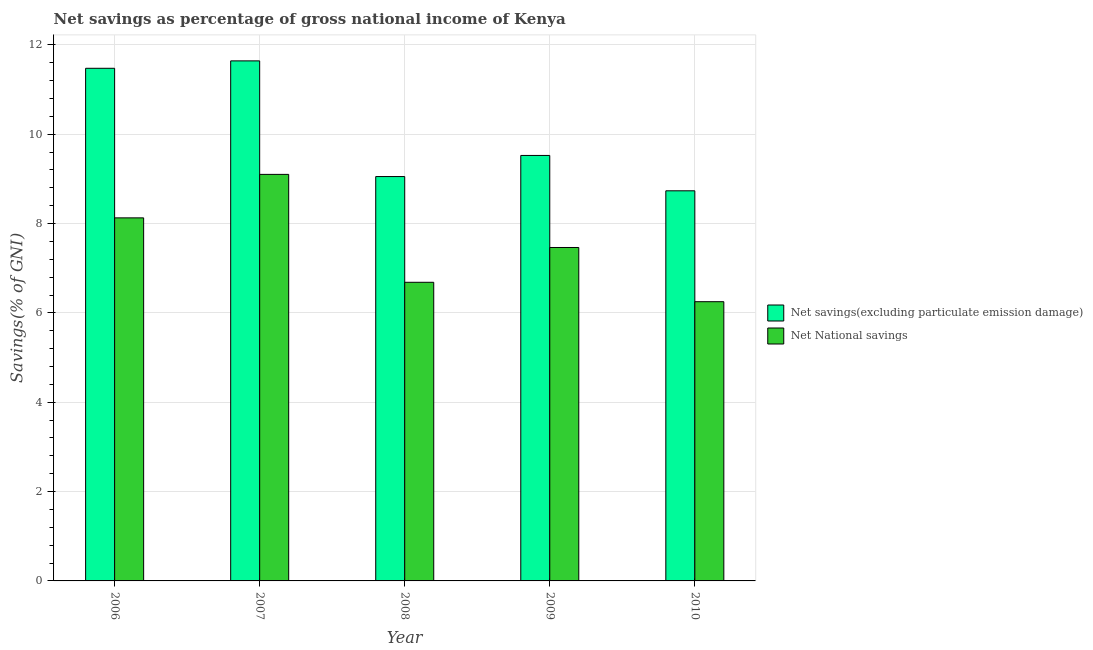How many different coloured bars are there?
Your answer should be very brief. 2. How many bars are there on the 3rd tick from the right?
Your answer should be very brief. 2. What is the net national savings in 2008?
Keep it short and to the point. 6.69. Across all years, what is the maximum net savings(excluding particulate emission damage)?
Give a very brief answer. 11.64. Across all years, what is the minimum net national savings?
Ensure brevity in your answer.  6.25. What is the total net savings(excluding particulate emission damage) in the graph?
Keep it short and to the point. 50.43. What is the difference between the net national savings in 2006 and that in 2010?
Ensure brevity in your answer.  1.88. What is the difference between the net savings(excluding particulate emission damage) in 2009 and the net national savings in 2010?
Offer a terse response. 0.79. What is the average net national savings per year?
Ensure brevity in your answer.  7.53. In how many years, is the net savings(excluding particulate emission damage) greater than 11.6 %?
Ensure brevity in your answer.  1. What is the ratio of the net savings(excluding particulate emission damage) in 2006 to that in 2007?
Offer a terse response. 0.99. Is the net national savings in 2006 less than that in 2010?
Give a very brief answer. No. Is the difference between the net national savings in 2009 and 2010 greater than the difference between the net savings(excluding particulate emission damage) in 2009 and 2010?
Offer a terse response. No. What is the difference between the highest and the second highest net national savings?
Make the answer very short. 0.97. What is the difference between the highest and the lowest net savings(excluding particulate emission damage)?
Make the answer very short. 2.91. In how many years, is the net savings(excluding particulate emission damage) greater than the average net savings(excluding particulate emission damage) taken over all years?
Offer a terse response. 2. Is the sum of the net savings(excluding particulate emission damage) in 2008 and 2009 greater than the maximum net national savings across all years?
Offer a very short reply. Yes. What does the 1st bar from the left in 2007 represents?
Provide a short and direct response. Net savings(excluding particulate emission damage). What does the 1st bar from the right in 2008 represents?
Provide a short and direct response. Net National savings. How many bars are there?
Provide a succinct answer. 10. How many years are there in the graph?
Your response must be concise. 5. What is the difference between two consecutive major ticks on the Y-axis?
Make the answer very short. 2. Does the graph contain grids?
Provide a succinct answer. Yes. How many legend labels are there?
Give a very brief answer. 2. What is the title of the graph?
Provide a succinct answer. Net savings as percentage of gross national income of Kenya. What is the label or title of the Y-axis?
Your answer should be very brief. Savings(% of GNI). What is the Savings(% of GNI) of Net savings(excluding particulate emission damage) in 2006?
Provide a short and direct response. 11.48. What is the Savings(% of GNI) of Net National savings in 2006?
Offer a terse response. 8.13. What is the Savings(% of GNI) of Net savings(excluding particulate emission damage) in 2007?
Provide a short and direct response. 11.64. What is the Savings(% of GNI) in Net National savings in 2007?
Offer a terse response. 9.1. What is the Savings(% of GNI) of Net savings(excluding particulate emission damage) in 2008?
Give a very brief answer. 9.05. What is the Savings(% of GNI) in Net National savings in 2008?
Your response must be concise. 6.69. What is the Savings(% of GNI) in Net savings(excluding particulate emission damage) in 2009?
Offer a very short reply. 9.53. What is the Savings(% of GNI) of Net National savings in 2009?
Provide a succinct answer. 7.46. What is the Savings(% of GNI) in Net savings(excluding particulate emission damage) in 2010?
Make the answer very short. 8.73. What is the Savings(% of GNI) in Net National savings in 2010?
Your response must be concise. 6.25. Across all years, what is the maximum Savings(% of GNI) of Net savings(excluding particulate emission damage)?
Provide a short and direct response. 11.64. Across all years, what is the maximum Savings(% of GNI) in Net National savings?
Your answer should be compact. 9.1. Across all years, what is the minimum Savings(% of GNI) of Net savings(excluding particulate emission damage)?
Your answer should be compact. 8.73. Across all years, what is the minimum Savings(% of GNI) of Net National savings?
Provide a short and direct response. 6.25. What is the total Savings(% of GNI) of Net savings(excluding particulate emission damage) in the graph?
Your answer should be compact. 50.43. What is the total Savings(% of GNI) in Net National savings in the graph?
Provide a short and direct response. 37.63. What is the difference between the Savings(% of GNI) in Net savings(excluding particulate emission damage) in 2006 and that in 2007?
Keep it short and to the point. -0.17. What is the difference between the Savings(% of GNI) in Net National savings in 2006 and that in 2007?
Offer a very short reply. -0.97. What is the difference between the Savings(% of GNI) in Net savings(excluding particulate emission damage) in 2006 and that in 2008?
Give a very brief answer. 2.42. What is the difference between the Savings(% of GNI) of Net National savings in 2006 and that in 2008?
Offer a terse response. 1.44. What is the difference between the Savings(% of GNI) of Net savings(excluding particulate emission damage) in 2006 and that in 2009?
Offer a very short reply. 1.95. What is the difference between the Savings(% of GNI) of Net National savings in 2006 and that in 2009?
Provide a succinct answer. 0.66. What is the difference between the Savings(% of GNI) in Net savings(excluding particulate emission damage) in 2006 and that in 2010?
Make the answer very short. 2.74. What is the difference between the Savings(% of GNI) in Net National savings in 2006 and that in 2010?
Make the answer very short. 1.88. What is the difference between the Savings(% of GNI) in Net savings(excluding particulate emission damage) in 2007 and that in 2008?
Your answer should be compact. 2.59. What is the difference between the Savings(% of GNI) in Net National savings in 2007 and that in 2008?
Make the answer very short. 2.42. What is the difference between the Savings(% of GNI) of Net savings(excluding particulate emission damage) in 2007 and that in 2009?
Ensure brevity in your answer.  2.12. What is the difference between the Savings(% of GNI) of Net National savings in 2007 and that in 2009?
Offer a terse response. 1.64. What is the difference between the Savings(% of GNI) in Net savings(excluding particulate emission damage) in 2007 and that in 2010?
Give a very brief answer. 2.91. What is the difference between the Savings(% of GNI) of Net National savings in 2007 and that in 2010?
Keep it short and to the point. 2.85. What is the difference between the Savings(% of GNI) of Net savings(excluding particulate emission damage) in 2008 and that in 2009?
Make the answer very short. -0.47. What is the difference between the Savings(% of GNI) of Net National savings in 2008 and that in 2009?
Offer a very short reply. -0.78. What is the difference between the Savings(% of GNI) in Net savings(excluding particulate emission damage) in 2008 and that in 2010?
Give a very brief answer. 0.32. What is the difference between the Savings(% of GNI) of Net National savings in 2008 and that in 2010?
Keep it short and to the point. 0.43. What is the difference between the Savings(% of GNI) of Net savings(excluding particulate emission damage) in 2009 and that in 2010?
Offer a terse response. 0.79. What is the difference between the Savings(% of GNI) of Net National savings in 2009 and that in 2010?
Give a very brief answer. 1.21. What is the difference between the Savings(% of GNI) of Net savings(excluding particulate emission damage) in 2006 and the Savings(% of GNI) of Net National savings in 2007?
Make the answer very short. 2.38. What is the difference between the Savings(% of GNI) of Net savings(excluding particulate emission damage) in 2006 and the Savings(% of GNI) of Net National savings in 2008?
Provide a succinct answer. 4.79. What is the difference between the Savings(% of GNI) in Net savings(excluding particulate emission damage) in 2006 and the Savings(% of GNI) in Net National savings in 2009?
Keep it short and to the point. 4.01. What is the difference between the Savings(% of GNI) of Net savings(excluding particulate emission damage) in 2006 and the Savings(% of GNI) of Net National savings in 2010?
Offer a very short reply. 5.23. What is the difference between the Savings(% of GNI) of Net savings(excluding particulate emission damage) in 2007 and the Savings(% of GNI) of Net National savings in 2008?
Offer a very short reply. 4.96. What is the difference between the Savings(% of GNI) in Net savings(excluding particulate emission damage) in 2007 and the Savings(% of GNI) in Net National savings in 2009?
Offer a very short reply. 4.18. What is the difference between the Savings(% of GNI) in Net savings(excluding particulate emission damage) in 2007 and the Savings(% of GNI) in Net National savings in 2010?
Offer a terse response. 5.39. What is the difference between the Savings(% of GNI) of Net savings(excluding particulate emission damage) in 2008 and the Savings(% of GNI) of Net National savings in 2009?
Provide a succinct answer. 1.59. What is the difference between the Savings(% of GNI) in Net savings(excluding particulate emission damage) in 2008 and the Savings(% of GNI) in Net National savings in 2010?
Provide a short and direct response. 2.8. What is the difference between the Savings(% of GNI) of Net savings(excluding particulate emission damage) in 2009 and the Savings(% of GNI) of Net National savings in 2010?
Give a very brief answer. 3.27. What is the average Savings(% of GNI) in Net savings(excluding particulate emission damage) per year?
Keep it short and to the point. 10.09. What is the average Savings(% of GNI) of Net National savings per year?
Your response must be concise. 7.53. In the year 2006, what is the difference between the Savings(% of GNI) in Net savings(excluding particulate emission damage) and Savings(% of GNI) in Net National savings?
Ensure brevity in your answer.  3.35. In the year 2007, what is the difference between the Savings(% of GNI) of Net savings(excluding particulate emission damage) and Savings(% of GNI) of Net National savings?
Your answer should be very brief. 2.54. In the year 2008, what is the difference between the Savings(% of GNI) of Net savings(excluding particulate emission damage) and Savings(% of GNI) of Net National savings?
Your answer should be very brief. 2.37. In the year 2009, what is the difference between the Savings(% of GNI) in Net savings(excluding particulate emission damage) and Savings(% of GNI) in Net National savings?
Provide a short and direct response. 2.06. In the year 2010, what is the difference between the Savings(% of GNI) of Net savings(excluding particulate emission damage) and Savings(% of GNI) of Net National savings?
Your answer should be very brief. 2.48. What is the ratio of the Savings(% of GNI) in Net savings(excluding particulate emission damage) in 2006 to that in 2007?
Offer a very short reply. 0.99. What is the ratio of the Savings(% of GNI) in Net National savings in 2006 to that in 2007?
Your answer should be compact. 0.89. What is the ratio of the Savings(% of GNI) of Net savings(excluding particulate emission damage) in 2006 to that in 2008?
Give a very brief answer. 1.27. What is the ratio of the Savings(% of GNI) of Net National savings in 2006 to that in 2008?
Your response must be concise. 1.22. What is the ratio of the Savings(% of GNI) of Net savings(excluding particulate emission damage) in 2006 to that in 2009?
Ensure brevity in your answer.  1.2. What is the ratio of the Savings(% of GNI) in Net National savings in 2006 to that in 2009?
Ensure brevity in your answer.  1.09. What is the ratio of the Savings(% of GNI) in Net savings(excluding particulate emission damage) in 2006 to that in 2010?
Provide a short and direct response. 1.31. What is the ratio of the Savings(% of GNI) of Net National savings in 2006 to that in 2010?
Offer a very short reply. 1.3. What is the ratio of the Savings(% of GNI) in Net savings(excluding particulate emission damage) in 2007 to that in 2008?
Offer a very short reply. 1.29. What is the ratio of the Savings(% of GNI) of Net National savings in 2007 to that in 2008?
Provide a short and direct response. 1.36. What is the ratio of the Savings(% of GNI) in Net savings(excluding particulate emission damage) in 2007 to that in 2009?
Your answer should be very brief. 1.22. What is the ratio of the Savings(% of GNI) of Net National savings in 2007 to that in 2009?
Provide a succinct answer. 1.22. What is the ratio of the Savings(% of GNI) in Net savings(excluding particulate emission damage) in 2007 to that in 2010?
Your response must be concise. 1.33. What is the ratio of the Savings(% of GNI) in Net National savings in 2007 to that in 2010?
Your response must be concise. 1.46. What is the ratio of the Savings(% of GNI) of Net savings(excluding particulate emission damage) in 2008 to that in 2009?
Provide a succinct answer. 0.95. What is the ratio of the Savings(% of GNI) of Net National savings in 2008 to that in 2009?
Keep it short and to the point. 0.9. What is the ratio of the Savings(% of GNI) in Net savings(excluding particulate emission damage) in 2008 to that in 2010?
Your response must be concise. 1.04. What is the ratio of the Savings(% of GNI) of Net National savings in 2008 to that in 2010?
Offer a terse response. 1.07. What is the ratio of the Savings(% of GNI) in Net savings(excluding particulate emission damage) in 2009 to that in 2010?
Provide a succinct answer. 1.09. What is the ratio of the Savings(% of GNI) in Net National savings in 2009 to that in 2010?
Provide a short and direct response. 1.19. What is the difference between the highest and the second highest Savings(% of GNI) of Net savings(excluding particulate emission damage)?
Offer a terse response. 0.17. What is the difference between the highest and the second highest Savings(% of GNI) in Net National savings?
Keep it short and to the point. 0.97. What is the difference between the highest and the lowest Savings(% of GNI) of Net savings(excluding particulate emission damage)?
Keep it short and to the point. 2.91. What is the difference between the highest and the lowest Savings(% of GNI) in Net National savings?
Your answer should be very brief. 2.85. 